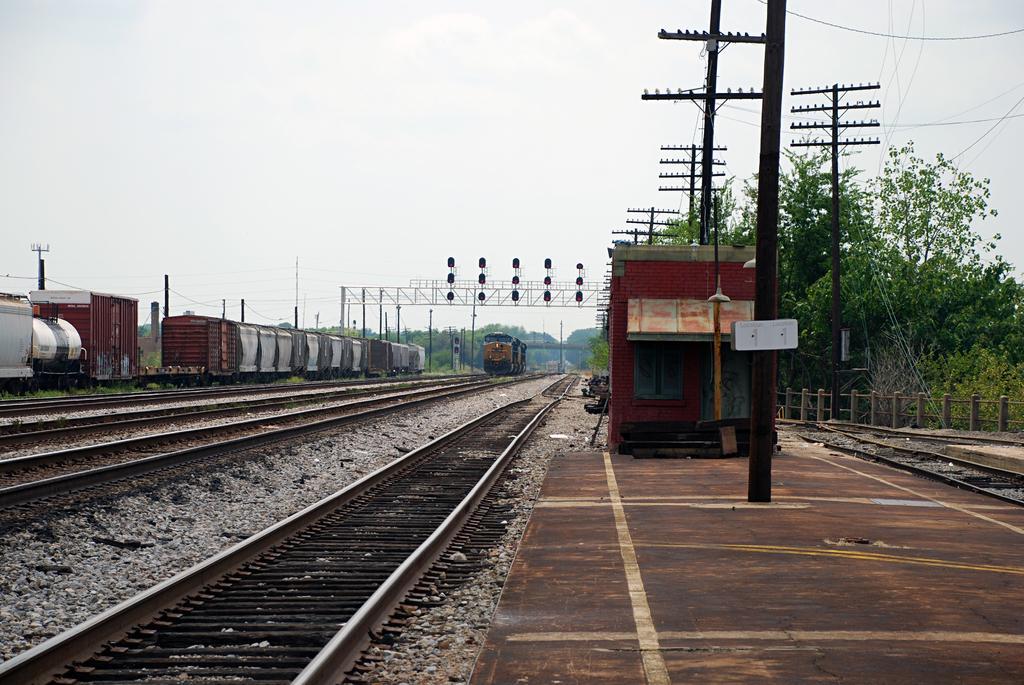In one or two sentences, can you explain what this image depicts? In this picture we can see trains on railway tracks,beside the railway tracks we can see poles,trees,traffic signals and we can see sky in the background. 